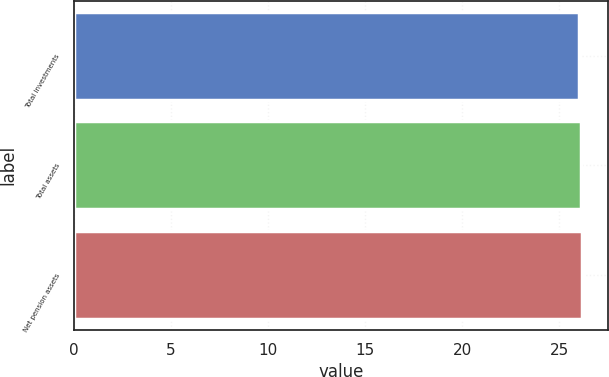Convert chart. <chart><loc_0><loc_0><loc_500><loc_500><bar_chart><fcel>Total investments<fcel>Total assets<fcel>Net pension assets<nl><fcel>26<fcel>26.1<fcel>26.2<nl></chart> 